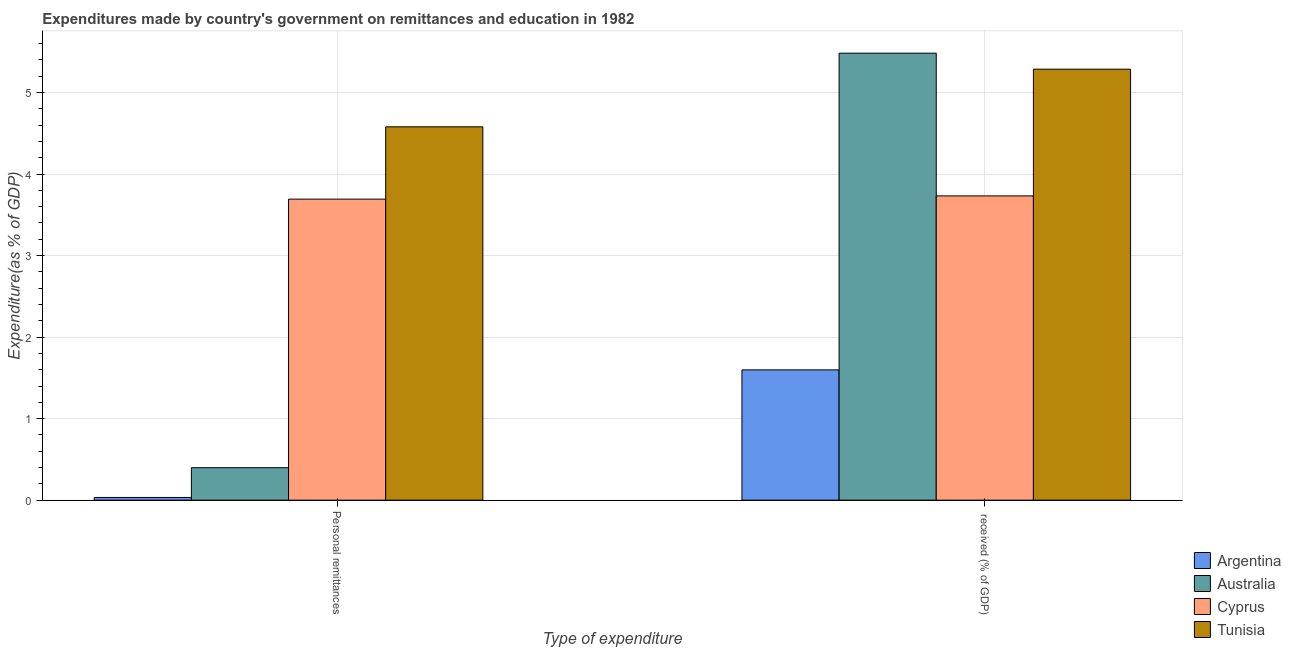How many bars are there on the 1st tick from the left?
Provide a succinct answer. 4. How many bars are there on the 1st tick from the right?
Ensure brevity in your answer.  4. What is the label of the 1st group of bars from the left?
Ensure brevity in your answer.  Personal remittances. What is the expenditure in personal remittances in Argentina?
Make the answer very short. 0.03. Across all countries, what is the maximum expenditure in personal remittances?
Offer a very short reply. 4.58. Across all countries, what is the minimum expenditure in personal remittances?
Your answer should be very brief. 0.03. In which country was the expenditure in personal remittances maximum?
Provide a succinct answer. Tunisia. What is the total expenditure in education in the graph?
Give a very brief answer. 16.1. What is the difference between the expenditure in education in Australia and that in Tunisia?
Your answer should be compact. 0.2. What is the difference between the expenditure in personal remittances in Tunisia and the expenditure in education in Argentina?
Offer a terse response. 2.98. What is the average expenditure in personal remittances per country?
Give a very brief answer. 2.18. What is the difference between the expenditure in personal remittances and expenditure in education in Australia?
Provide a short and direct response. -5.08. What is the ratio of the expenditure in personal remittances in Australia to that in Argentina?
Provide a short and direct response. 11.99. Is the expenditure in education in Tunisia less than that in Australia?
Your response must be concise. Yes. What does the 2nd bar from the left in  received (% of GDP) represents?
Ensure brevity in your answer.  Australia. What does the 2nd bar from the right in Personal remittances represents?
Offer a very short reply. Cyprus. How many countries are there in the graph?
Provide a succinct answer. 4. Does the graph contain any zero values?
Offer a very short reply. No. Does the graph contain grids?
Offer a very short reply. Yes. Where does the legend appear in the graph?
Ensure brevity in your answer.  Bottom right. What is the title of the graph?
Keep it short and to the point. Expenditures made by country's government on remittances and education in 1982. What is the label or title of the X-axis?
Provide a short and direct response. Type of expenditure. What is the label or title of the Y-axis?
Ensure brevity in your answer.  Expenditure(as % of GDP). What is the Expenditure(as % of GDP) in Argentina in Personal remittances?
Offer a very short reply. 0.03. What is the Expenditure(as % of GDP) in Australia in Personal remittances?
Your answer should be compact. 0.4. What is the Expenditure(as % of GDP) of Cyprus in Personal remittances?
Ensure brevity in your answer.  3.69. What is the Expenditure(as % of GDP) in Tunisia in Personal remittances?
Ensure brevity in your answer.  4.58. What is the Expenditure(as % of GDP) of Argentina in  received (% of GDP)?
Ensure brevity in your answer.  1.6. What is the Expenditure(as % of GDP) in Australia in  received (% of GDP)?
Your response must be concise. 5.48. What is the Expenditure(as % of GDP) in Cyprus in  received (% of GDP)?
Your answer should be compact. 3.73. What is the Expenditure(as % of GDP) in Tunisia in  received (% of GDP)?
Make the answer very short. 5.29. Across all Type of expenditure, what is the maximum Expenditure(as % of GDP) in Argentina?
Ensure brevity in your answer.  1.6. Across all Type of expenditure, what is the maximum Expenditure(as % of GDP) in Australia?
Your answer should be compact. 5.48. Across all Type of expenditure, what is the maximum Expenditure(as % of GDP) of Cyprus?
Ensure brevity in your answer.  3.73. Across all Type of expenditure, what is the maximum Expenditure(as % of GDP) of Tunisia?
Give a very brief answer. 5.29. Across all Type of expenditure, what is the minimum Expenditure(as % of GDP) of Argentina?
Your answer should be very brief. 0.03. Across all Type of expenditure, what is the minimum Expenditure(as % of GDP) of Australia?
Make the answer very short. 0.4. Across all Type of expenditure, what is the minimum Expenditure(as % of GDP) of Cyprus?
Offer a terse response. 3.69. Across all Type of expenditure, what is the minimum Expenditure(as % of GDP) in Tunisia?
Make the answer very short. 4.58. What is the total Expenditure(as % of GDP) of Argentina in the graph?
Provide a short and direct response. 1.63. What is the total Expenditure(as % of GDP) in Australia in the graph?
Give a very brief answer. 5.88. What is the total Expenditure(as % of GDP) in Cyprus in the graph?
Ensure brevity in your answer.  7.42. What is the total Expenditure(as % of GDP) of Tunisia in the graph?
Keep it short and to the point. 9.87. What is the difference between the Expenditure(as % of GDP) of Argentina in Personal remittances and that in  received (% of GDP)?
Your answer should be compact. -1.56. What is the difference between the Expenditure(as % of GDP) of Australia in Personal remittances and that in  received (% of GDP)?
Your response must be concise. -5.08. What is the difference between the Expenditure(as % of GDP) in Cyprus in Personal remittances and that in  received (% of GDP)?
Your response must be concise. -0.04. What is the difference between the Expenditure(as % of GDP) of Tunisia in Personal remittances and that in  received (% of GDP)?
Offer a terse response. -0.71. What is the difference between the Expenditure(as % of GDP) in Argentina in Personal remittances and the Expenditure(as % of GDP) in Australia in  received (% of GDP)?
Your answer should be compact. -5.45. What is the difference between the Expenditure(as % of GDP) of Argentina in Personal remittances and the Expenditure(as % of GDP) of Cyprus in  received (% of GDP)?
Keep it short and to the point. -3.7. What is the difference between the Expenditure(as % of GDP) of Argentina in Personal remittances and the Expenditure(as % of GDP) of Tunisia in  received (% of GDP)?
Provide a succinct answer. -5.25. What is the difference between the Expenditure(as % of GDP) of Australia in Personal remittances and the Expenditure(as % of GDP) of Cyprus in  received (% of GDP)?
Give a very brief answer. -3.33. What is the difference between the Expenditure(as % of GDP) in Australia in Personal remittances and the Expenditure(as % of GDP) in Tunisia in  received (% of GDP)?
Keep it short and to the point. -4.89. What is the difference between the Expenditure(as % of GDP) of Cyprus in Personal remittances and the Expenditure(as % of GDP) of Tunisia in  received (% of GDP)?
Your response must be concise. -1.59. What is the average Expenditure(as % of GDP) in Argentina per Type of expenditure?
Offer a terse response. 0.82. What is the average Expenditure(as % of GDP) in Australia per Type of expenditure?
Make the answer very short. 2.94. What is the average Expenditure(as % of GDP) in Cyprus per Type of expenditure?
Provide a short and direct response. 3.71. What is the average Expenditure(as % of GDP) in Tunisia per Type of expenditure?
Give a very brief answer. 4.93. What is the difference between the Expenditure(as % of GDP) in Argentina and Expenditure(as % of GDP) in Australia in Personal remittances?
Give a very brief answer. -0.36. What is the difference between the Expenditure(as % of GDP) in Argentina and Expenditure(as % of GDP) in Cyprus in Personal remittances?
Keep it short and to the point. -3.66. What is the difference between the Expenditure(as % of GDP) in Argentina and Expenditure(as % of GDP) in Tunisia in Personal remittances?
Your answer should be very brief. -4.55. What is the difference between the Expenditure(as % of GDP) in Australia and Expenditure(as % of GDP) in Cyprus in Personal remittances?
Offer a terse response. -3.29. What is the difference between the Expenditure(as % of GDP) in Australia and Expenditure(as % of GDP) in Tunisia in Personal remittances?
Provide a succinct answer. -4.18. What is the difference between the Expenditure(as % of GDP) of Cyprus and Expenditure(as % of GDP) of Tunisia in Personal remittances?
Give a very brief answer. -0.89. What is the difference between the Expenditure(as % of GDP) in Argentina and Expenditure(as % of GDP) in Australia in  received (% of GDP)?
Provide a short and direct response. -3.88. What is the difference between the Expenditure(as % of GDP) in Argentina and Expenditure(as % of GDP) in Cyprus in  received (% of GDP)?
Keep it short and to the point. -2.13. What is the difference between the Expenditure(as % of GDP) of Argentina and Expenditure(as % of GDP) of Tunisia in  received (% of GDP)?
Give a very brief answer. -3.69. What is the difference between the Expenditure(as % of GDP) in Australia and Expenditure(as % of GDP) in Cyprus in  received (% of GDP)?
Give a very brief answer. 1.75. What is the difference between the Expenditure(as % of GDP) in Australia and Expenditure(as % of GDP) in Tunisia in  received (% of GDP)?
Offer a very short reply. 0.2. What is the difference between the Expenditure(as % of GDP) of Cyprus and Expenditure(as % of GDP) of Tunisia in  received (% of GDP)?
Provide a succinct answer. -1.55. What is the ratio of the Expenditure(as % of GDP) of Argentina in Personal remittances to that in  received (% of GDP)?
Your response must be concise. 0.02. What is the ratio of the Expenditure(as % of GDP) of Australia in Personal remittances to that in  received (% of GDP)?
Ensure brevity in your answer.  0.07. What is the ratio of the Expenditure(as % of GDP) in Tunisia in Personal remittances to that in  received (% of GDP)?
Make the answer very short. 0.87. What is the difference between the highest and the second highest Expenditure(as % of GDP) of Argentina?
Your answer should be compact. 1.56. What is the difference between the highest and the second highest Expenditure(as % of GDP) of Australia?
Ensure brevity in your answer.  5.08. What is the difference between the highest and the second highest Expenditure(as % of GDP) in Cyprus?
Your answer should be very brief. 0.04. What is the difference between the highest and the second highest Expenditure(as % of GDP) in Tunisia?
Provide a short and direct response. 0.71. What is the difference between the highest and the lowest Expenditure(as % of GDP) in Argentina?
Offer a very short reply. 1.56. What is the difference between the highest and the lowest Expenditure(as % of GDP) of Australia?
Offer a very short reply. 5.08. What is the difference between the highest and the lowest Expenditure(as % of GDP) in Cyprus?
Offer a terse response. 0.04. What is the difference between the highest and the lowest Expenditure(as % of GDP) in Tunisia?
Your response must be concise. 0.71. 